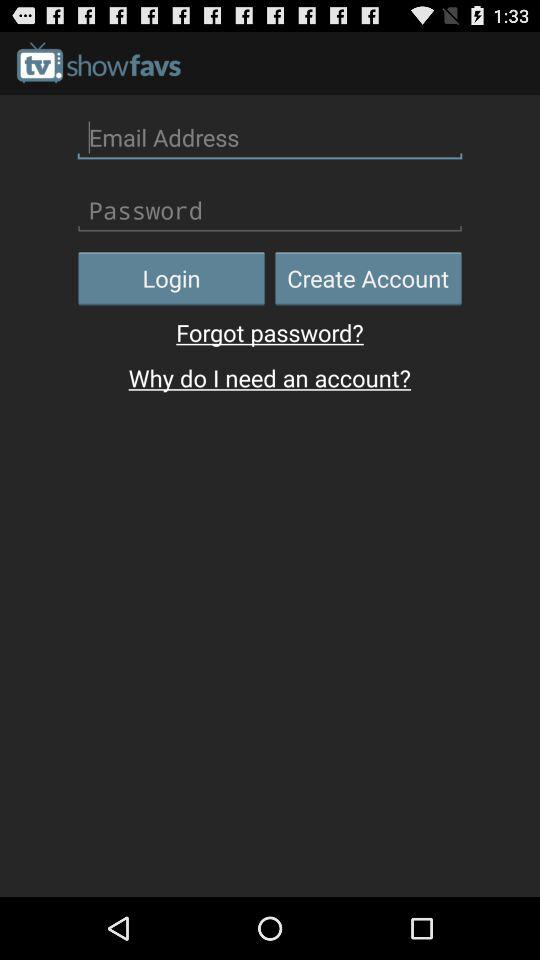What is the app name? The app name is "Information Biss Key". 